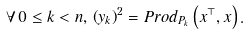Convert formula to latex. <formula><loc_0><loc_0><loc_500><loc_500>\forall \, 0 \leq k < n , \, \left ( y _ { k } \right ) ^ { 2 } = P r o d _ { P _ { k } } \left ( x ^ { \top } , x \right ) .</formula> 